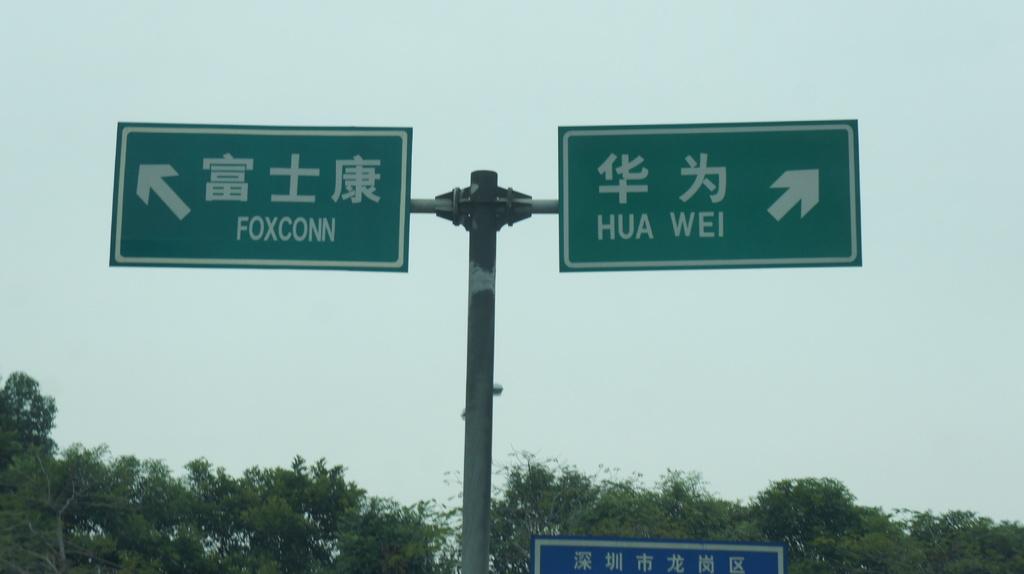Where do these routes go?
Keep it short and to the point. Foxconn, hua wei. What does the right sign say?
Your response must be concise. Hua wei. 